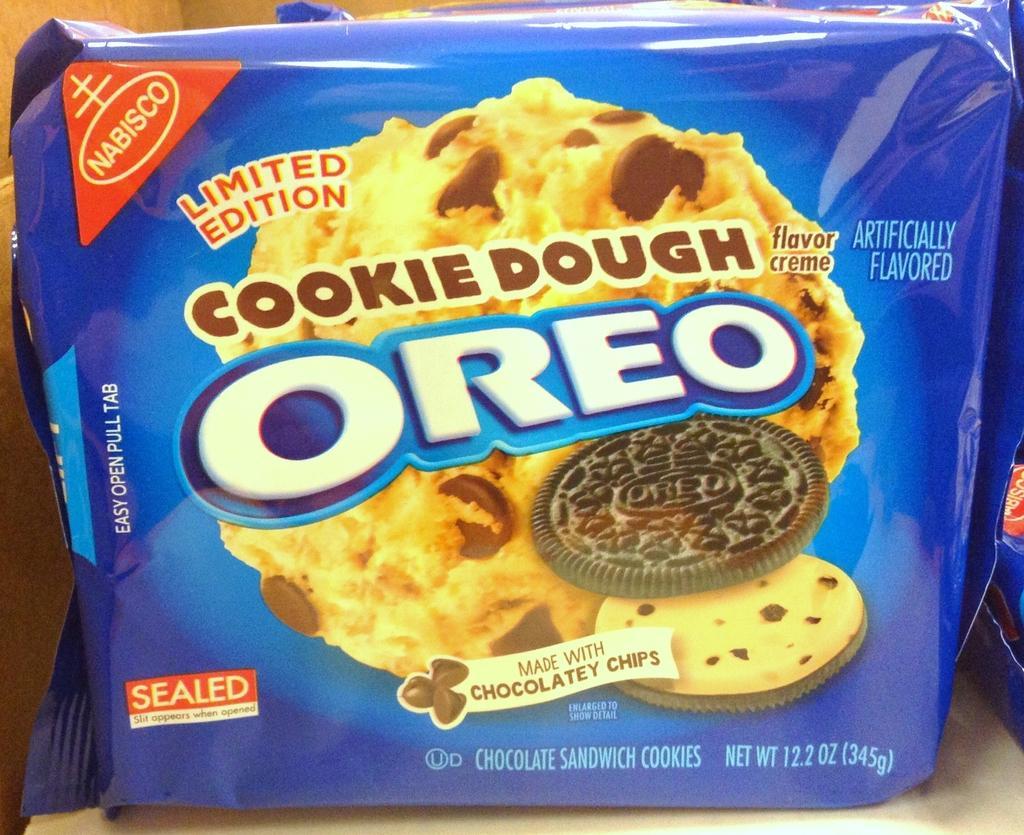Please provide a concise description of this image. It is a zoomed in picture of a Oreo biscuit packet and the packet is placed on the surface. We can see the picture of a biscuit and we can also see the text on the packet. 